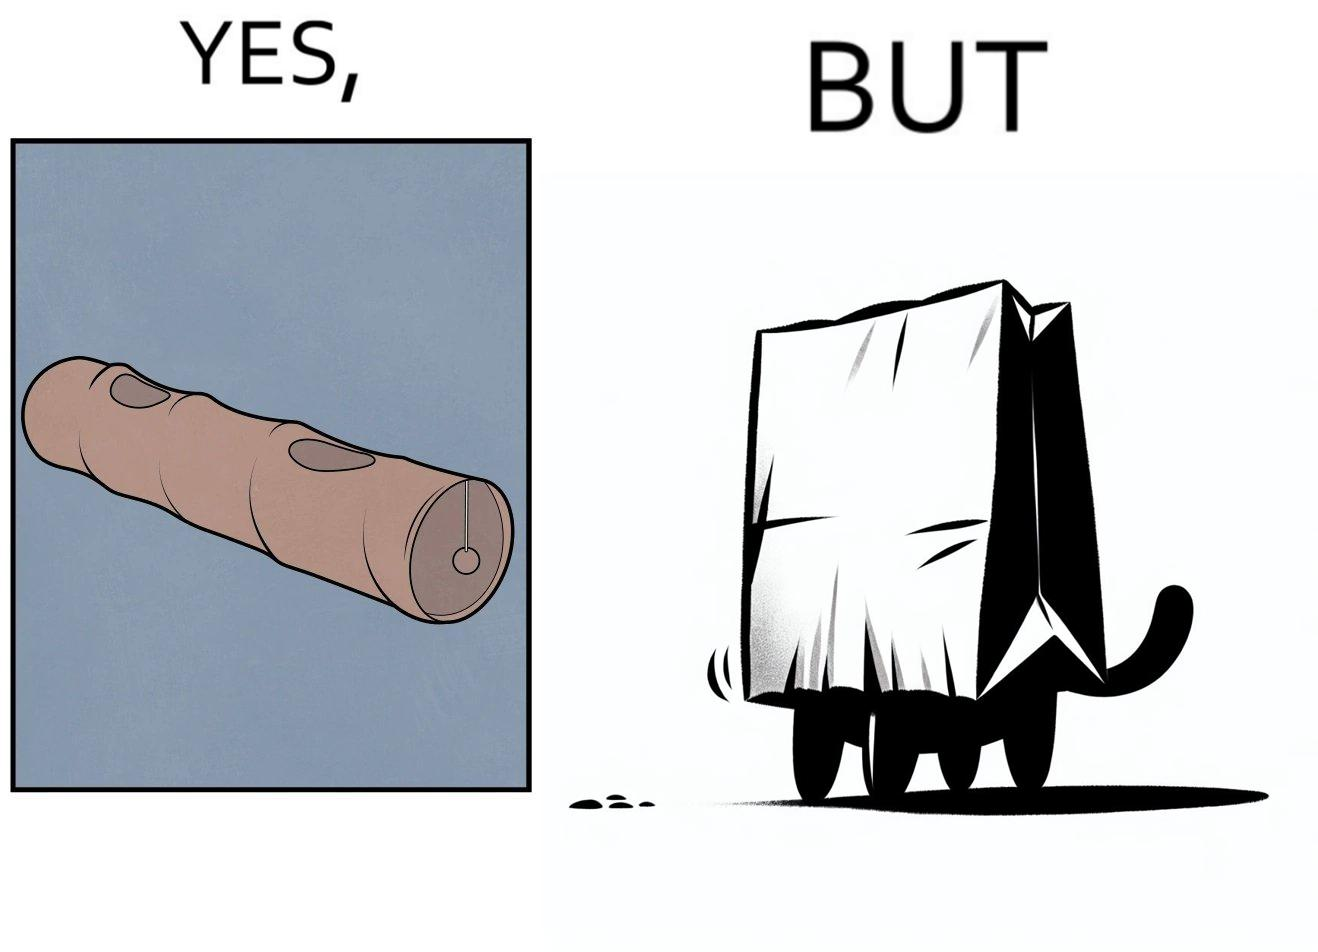What is the satirical meaning behind this image? The image is funny, because even when there is a dedicated thing for the animal to play with it still is hiding itself in the paper bag 